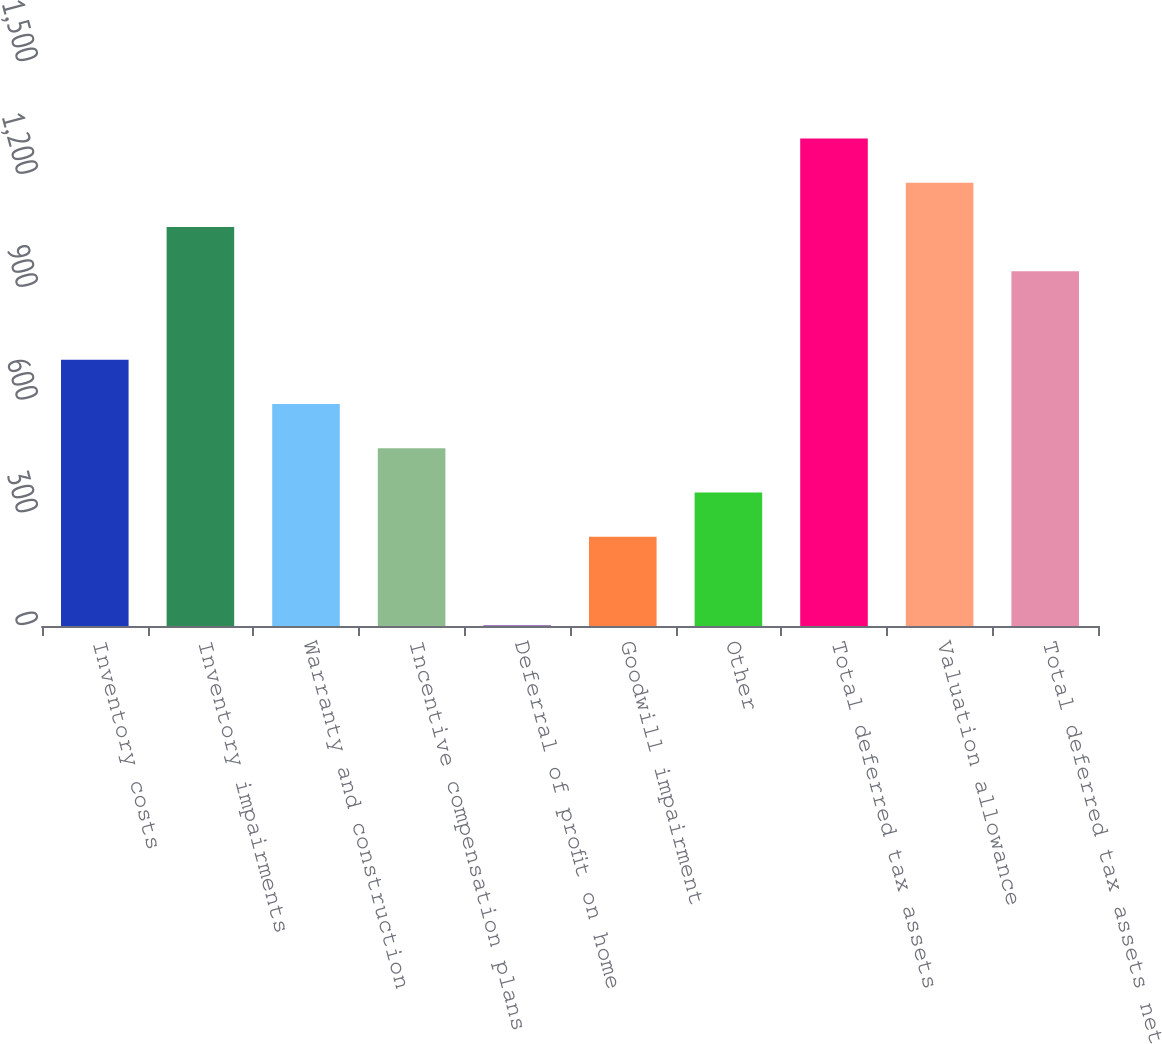<chart> <loc_0><loc_0><loc_500><loc_500><bar_chart><fcel>Inventory costs<fcel>Inventory impairments<fcel>Warranty and construction<fcel>Incentive compensation plans<fcel>Deferral of profit on home<fcel>Goodwill impairment<fcel>Other<fcel>Total deferred tax assets<fcel>Valuation allowance<fcel>Total deferred tax assets net<nl><fcel>708.04<fcel>1061.26<fcel>590.3<fcel>472.56<fcel>1.6<fcel>237.08<fcel>354.82<fcel>1296.74<fcel>1179<fcel>943.52<nl></chart> 